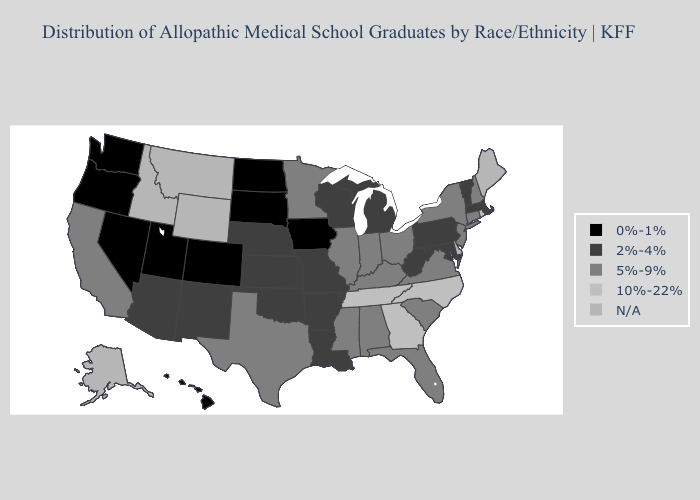What is the value of Alabama?
Write a very short answer. 5%-9%. Among the states that border Oklahoma , does Texas have the lowest value?
Answer briefly. No. What is the lowest value in states that border Iowa?
Be succinct. 0%-1%. Name the states that have a value in the range 2%-4%?
Write a very short answer. Arizona, Arkansas, Kansas, Louisiana, Maryland, Massachusetts, Michigan, Missouri, Nebraska, New Mexico, Oklahoma, Pennsylvania, Vermont, West Virginia, Wisconsin. How many symbols are there in the legend?
Short answer required. 5. Name the states that have a value in the range 5%-9%?
Be succinct. Alabama, California, Connecticut, Florida, Illinois, Indiana, Kentucky, Minnesota, Mississippi, New Hampshire, New Jersey, New York, Ohio, South Carolina, Texas, Virginia. What is the value of Arkansas?
Be succinct. 2%-4%. What is the value of Massachusetts?
Answer briefly. 2%-4%. What is the highest value in the West ?
Short answer required. 5%-9%. Does Rhode Island have the highest value in the Northeast?
Write a very short answer. Yes. Name the states that have a value in the range N/A?
Keep it brief. Alaska, Delaware, Idaho, Maine, Montana, Wyoming. Which states hav the highest value in the West?
Write a very short answer. California. Name the states that have a value in the range 0%-1%?
Be succinct. Colorado, Hawaii, Iowa, Nevada, North Dakota, Oregon, South Dakota, Utah, Washington. Does Nevada have the lowest value in the USA?
Keep it brief. Yes. 